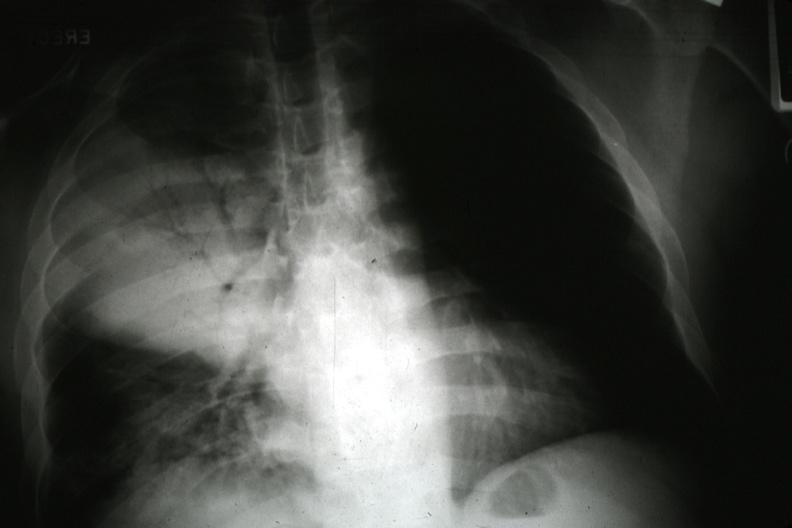what does this image show?
Answer the question using a single word or phrase. Chest x ray 34 year old alcoholic with lobar pneumonia and fulminant sepsis blood culture pneumococcus and klebsiella 